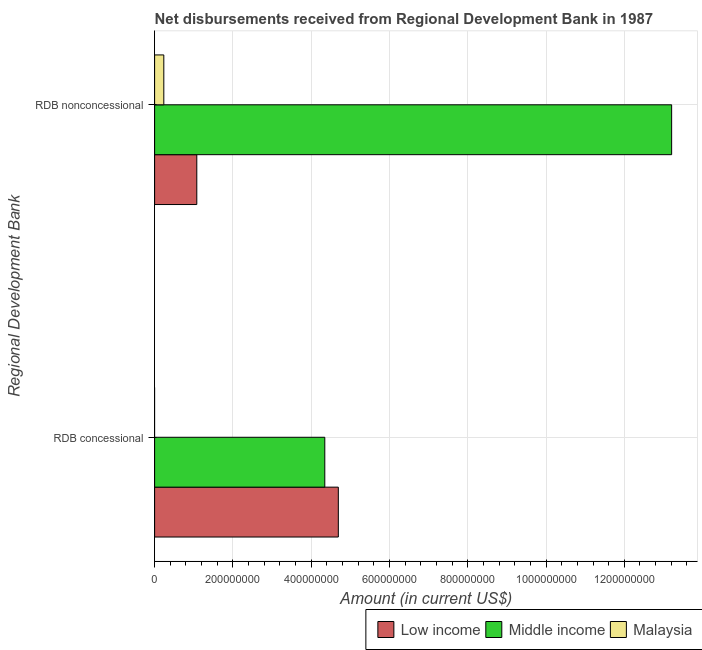Are the number of bars on each tick of the Y-axis equal?
Ensure brevity in your answer.  No. How many bars are there on the 2nd tick from the bottom?
Make the answer very short. 3. What is the label of the 1st group of bars from the top?
Provide a short and direct response. RDB nonconcessional. What is the net concessional disbursements from rdb in Malaysia?
Your answer should be very brief. 0. Across all countries, what is the maximum net non concessional disbursements from rdb?
Offer a very short reply. 1.32e+09. Across all countries, what is the minimum net non concessional disbursements from rdb?
Your answer should be compact. 2.35e+07. In which country was the net concessional disbursements from rdb maximum?
Provide a short and direct response. Low income. What is the total net non concessional disbursements from rdb in the graph?
Make the answer very short. 1.45e+09. What is the difference between the net non concessional disbursements from rdb in Malaysia and that in Middle income?
Your answer should be very brief. -1.30e+09. What is the difference between the net concessional disbursements from rdb in Malaysia and the net non concessional disbursements from rdb in Middle income?
Offer a very short reply. -1.32e+09. What is the average net concessional disbursements from rdb per country?
Your answer should be compact. 3.01e+08. What is the difference between the net non concessional disbursements from rdb and net concessional disbursements from rdb in Middle income?
Ensure brevity in your answer.  8.86e+08. In how many countries, is the net non concessional disbursements from rdb greater than 1240000000 US$?
Provide a short and direct response. 1. What is the ratio of the net non concessional disbursements from rdb in Malaysia to that in Low income?
Keep it short and to the point. 0.22. In how many countries, is the net non concessional disbursements from rdb greater than the average net non concessional disbursements from rdb taken over all countries?
Offer a terse response. 1. How many countries are there in the graph?
Offer a very short reply. 3. Are the values on the major ticks of X-axis written in scientific E-notation?
Your answer should be very brief. No. What is the title of the graph?
Offer a very short reply. Net disbursements received from Regional Development Bank in 1987. What is the label or title of the Y-axis?
Provide a succinct answer. Regional Development Bank. What is the Amount (in current US$) in Low income in RDB concessional?
Your answer should be compact. 4.69e+08. What is the Amount (in current US$) of Middle income in RDB concessional?
Your response must be concise. 4.35e+08. What is the Amount (in current US$) in Malaysia in RDB concessional?
Ensure brevity in your answer.  0. What is the Amount (in current US$) in Low income in RDB nonconcessional?
Offer a very short reply. 1.08e+08. What is the Amount (in current US$) of Middle income in RDB nonconcessional?
Make the answer very short. 1.32e+09. What is the Amount (in current US$) of Malaysia in RDB nonconcessional?
Your response must be concise. 2.35e+07. Across all Regional Development Bank, what is the maximum Amount (in current US$) in Low income?
Ensure brevity in your answer.  4.69e+08. Across all Regional Development Bank, what is the maximum Amount (in current US$) of Middle income?
Your answer should be very brief. 1.32e+09. Across all Regional Development Bank, what is the maximum Amount (in current US$) in Malaysia?
Keep it short and to the point. 2.35e+07. Across all Regional Development Bank, what is the minimum Amount (in current US$) of Low income?
Keep it short and to the point. 1.08e+08. Across all Regional Development Bank, what is the minimum Amount (in current US$) of Middle income?
Make the answer very short. 4.35e+08. What is the total Amount (in current US$) of Low income in the graph?
Provide a succinct answer. 5.77e+08. What is the total Amount (in current US$) of Middle income in the graph?
Make the answer very short. 1.76e+09. What is the total Amount (in current US$) of Malaysia in the graph?
Provide a short and direct response. 2.35e+07. What is the difference between the Amount (in current US$) in Low income in RDB concessional and that in RDB nonconcessional?
Make the answer very short. 3.62e+08. What is the difference between the Amount (in current US$) in Middle income in RDB concessional and that in RDB nonconcessional?
Give a very brief answer. -8.86e+08. What is the difference between the Amount (in current US$) of Low income in RDB concessional and the Amount (in current US$) of Middle income in RDB nonconcessional?
Your response must be concise. -8.52e+08. What is the difference between the Amount (in current US$) of Low income in RDB concessional and the Amount (in current US$) of Malaysia in RDB nonconcessional?
Provide a succinct answer. 4.46e+08. What is the difference between the Amount (in current US$) in Middle income in RDB concessional and the Amount (in current US$) in Malaysia in RDB nonconcessional?
Your response must be concise. 4.11e+08. What is the average Amount (in current US$) of Low income per Regional Development Bank?
Offer a terse response. 2.89e+08. What is the average Amount (in current US$) of Middle income per Regional Development Bank?
Offer a very short reply. 8.78e+08. What is the average Amount (in current US$) of Malaysia per Regional Development Bank?
Keep it short and to the point. 1.18e+07. What is the difference between the Amount (in current US$) in Low income and Amount (in current US$) in Middle income in RDB concessional?
Provide a succinct answer. 3.45e+07. What is the difference between the Amount (in current US$) in Low income and Amount (in current US$) in Middle income in RDB nonconcessional?
Your response must be concise. -1.21e+09. What is the difference between the Amount (in current US$) of Low income and Amount (in current US$) of Malaysia in RDB nonconcessional?
Give a very brief answer. 8.43e+07. What is the difference between the Amount (in current US$) of Middle income and Amount (in current US$) of Malaysia in RDB nonconcessional?
Offer a terse response. 1.30e+09. What is the ratio of the Amount (in current US$) in Low income in RDB concessional to that in RDB nonconcessional?
Your answer should be compact. 4.35. What is the ratio of the Amount (in current US$) of Middle income in RDB concessional to that in RDB nonconcessional?
Offer a very short reply. 0.33. What is the difference between the highest and the second highest Amount (in current US$) of Low income?
Provide a short and direct response. 3.62e+08. What is the difference between the highest and the second highest Amount (in current US$) in Middle income?
Make the answer very short. 8.86e+08. What is the difference between the highest and the lowest Amount (in current US$) in Low income?
Give a very brief answer. 3.62e+08. What is the difference between the highest and the lowest Amount (in current US$) of Middle income?
Your answer should be compact. 8.86e+08. What is the difference between the highest and the lowest Amount (in current US$) of Malaysia?
Ensure brevity in your answer.  2.35e+07. 